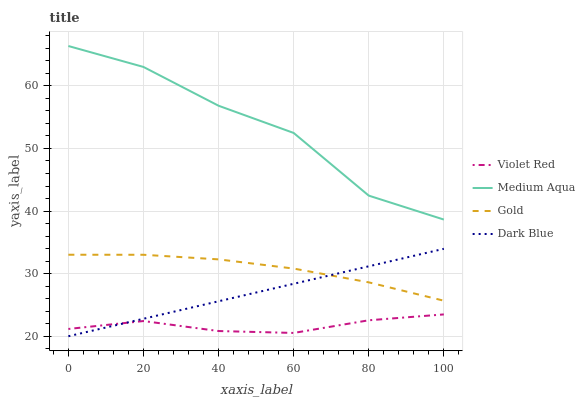Does Violet Red have the minimum area under the curve?
Answer yes or no. Yes. Does Medium Aqua have the minimum area under the curve?
Answer yes or no. No. Does Violet Red have the maximum area under the curve?
Answer yes or no. No. Is Medium Aqua the roughest?
Answer yes or no. Yes. Is Violet Red the smoothest?
Answer yes or no. No. Is Violet Red the roughest?
Answer yes or no. No. Does Violet Red have the lowest value?
Answer yes or no. No. Does Violet Red have the highest value?
Answer yes or no. No. Is Violet Red less than Medium Aqua?
Answer yes or no. Yes. Is Medium Aqua greater than Dark Blue?
Answer yes or no. Yes. Does Violet Red intersect Medium Aqua?
Answer yes or no. No. 